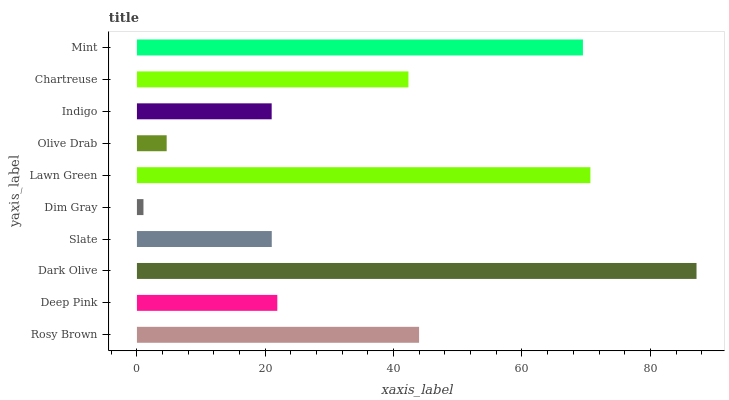Is Dim Gray the minimum?
Answer yes or no. Yes. Is Dark Olive the maximum?
Answer yes or no. Yes. Is Deep Pink the minimum?
Answer yes or no. No. Is Deep Pink the maximum?
Answer yes or no. No. Is Rosy Brown greater than Deep Pink?
Answer yes or no. Yes. Is Deep Pink less than Rosy Brown?
Answer yes or no. Yes. Is Deep Pink greater than Rosy Brown?
Answer yes or no. No. Is Rosy Brown less than Deep Pink?
Answer yes or no. No. Is Chartreuse the high median?
Answer yes or no. Yes. Is Deep Pink the low median?
Answer yes or no. Yes. Is Indigo the high median?
Answer yes or no. No. Is Rosy Brown the low median?
Answer yes or no. No. 